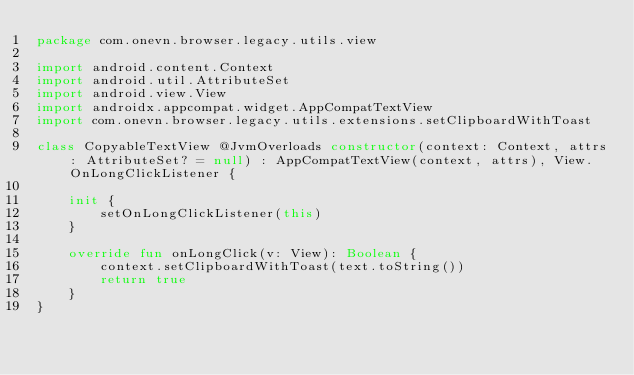<code> <loc_0><loc_0><loc_500><loc_500><_Kotlin_>package com.onevn.browser.legacy.utils.view

import android.content.Context
import android.util.AttributeSet
import android.view.View
import androidx.appcompat.widget.AppCompatTextView
import com.onevn.browser.legacy.utils.extensions.setClipboardWithToast

class CopyableTextView @JvmOverloads constructor(context: Context, attrs: AttributeSet? = null) : AppCompatTextView(context, attrs), View.OnLongClickListener {

    init {
        setOnLongClickListener(this)
    }

    override fun onLongClick(v: View): Boolean {
        context.setClipboardWithToast(text.toString())
        return true
    }
}
</code> 